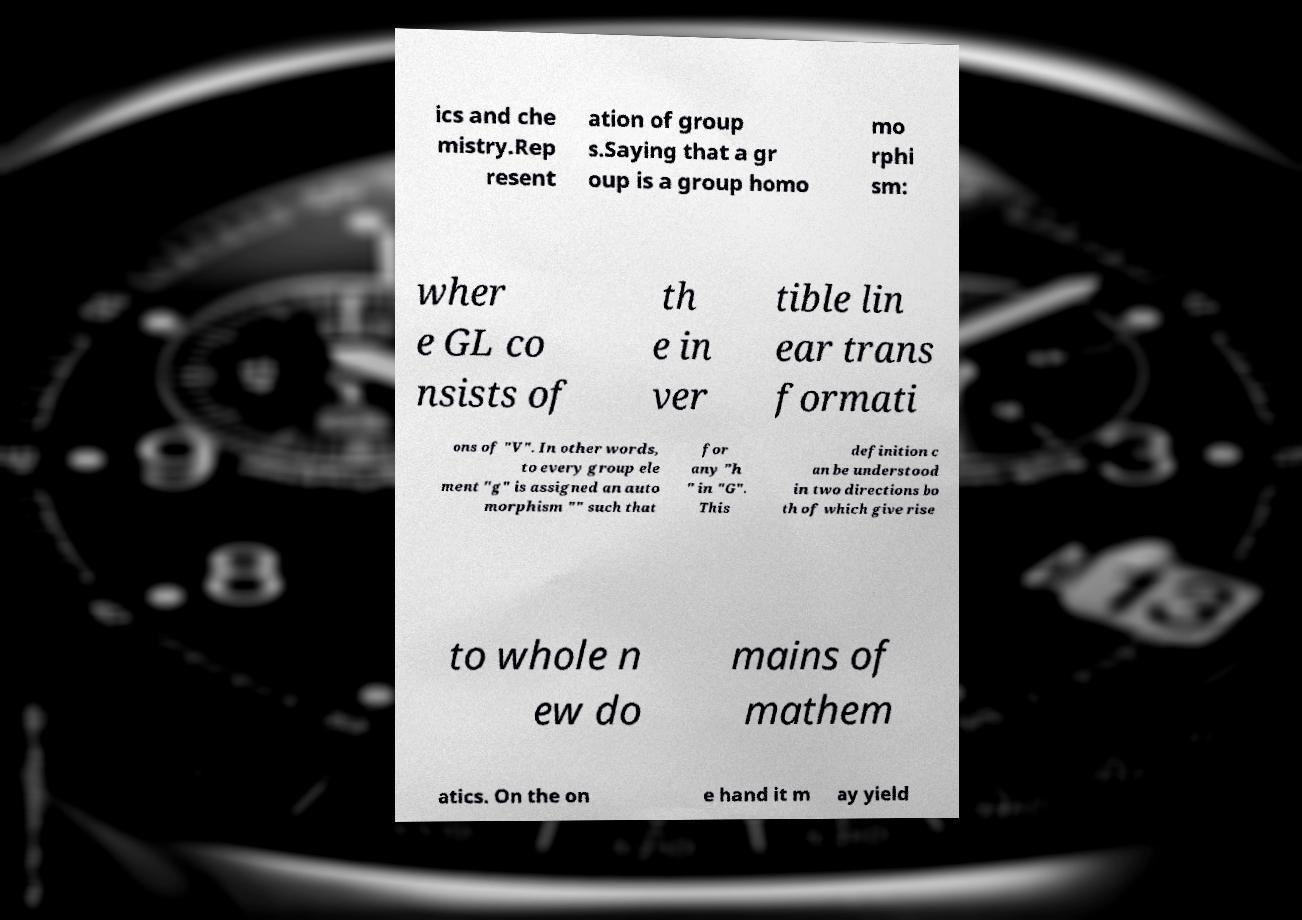Can you accurately transcribe the text from the provided image for me? ics and che mistry.Rep resent ation of group s.Saying that a gr oup is a group homo mo rphi sm: wher e GL co nsists of th e in ver tible lin ear trans formati ons of "V". In other words, to every group ele ment "g" is assigned an auto morphism "" such that for any "h " in "G". This definition c an be understood in two directions bo th of which give rise to whole n ew do mains of mathem atics. On the on e hand it m ay yield 